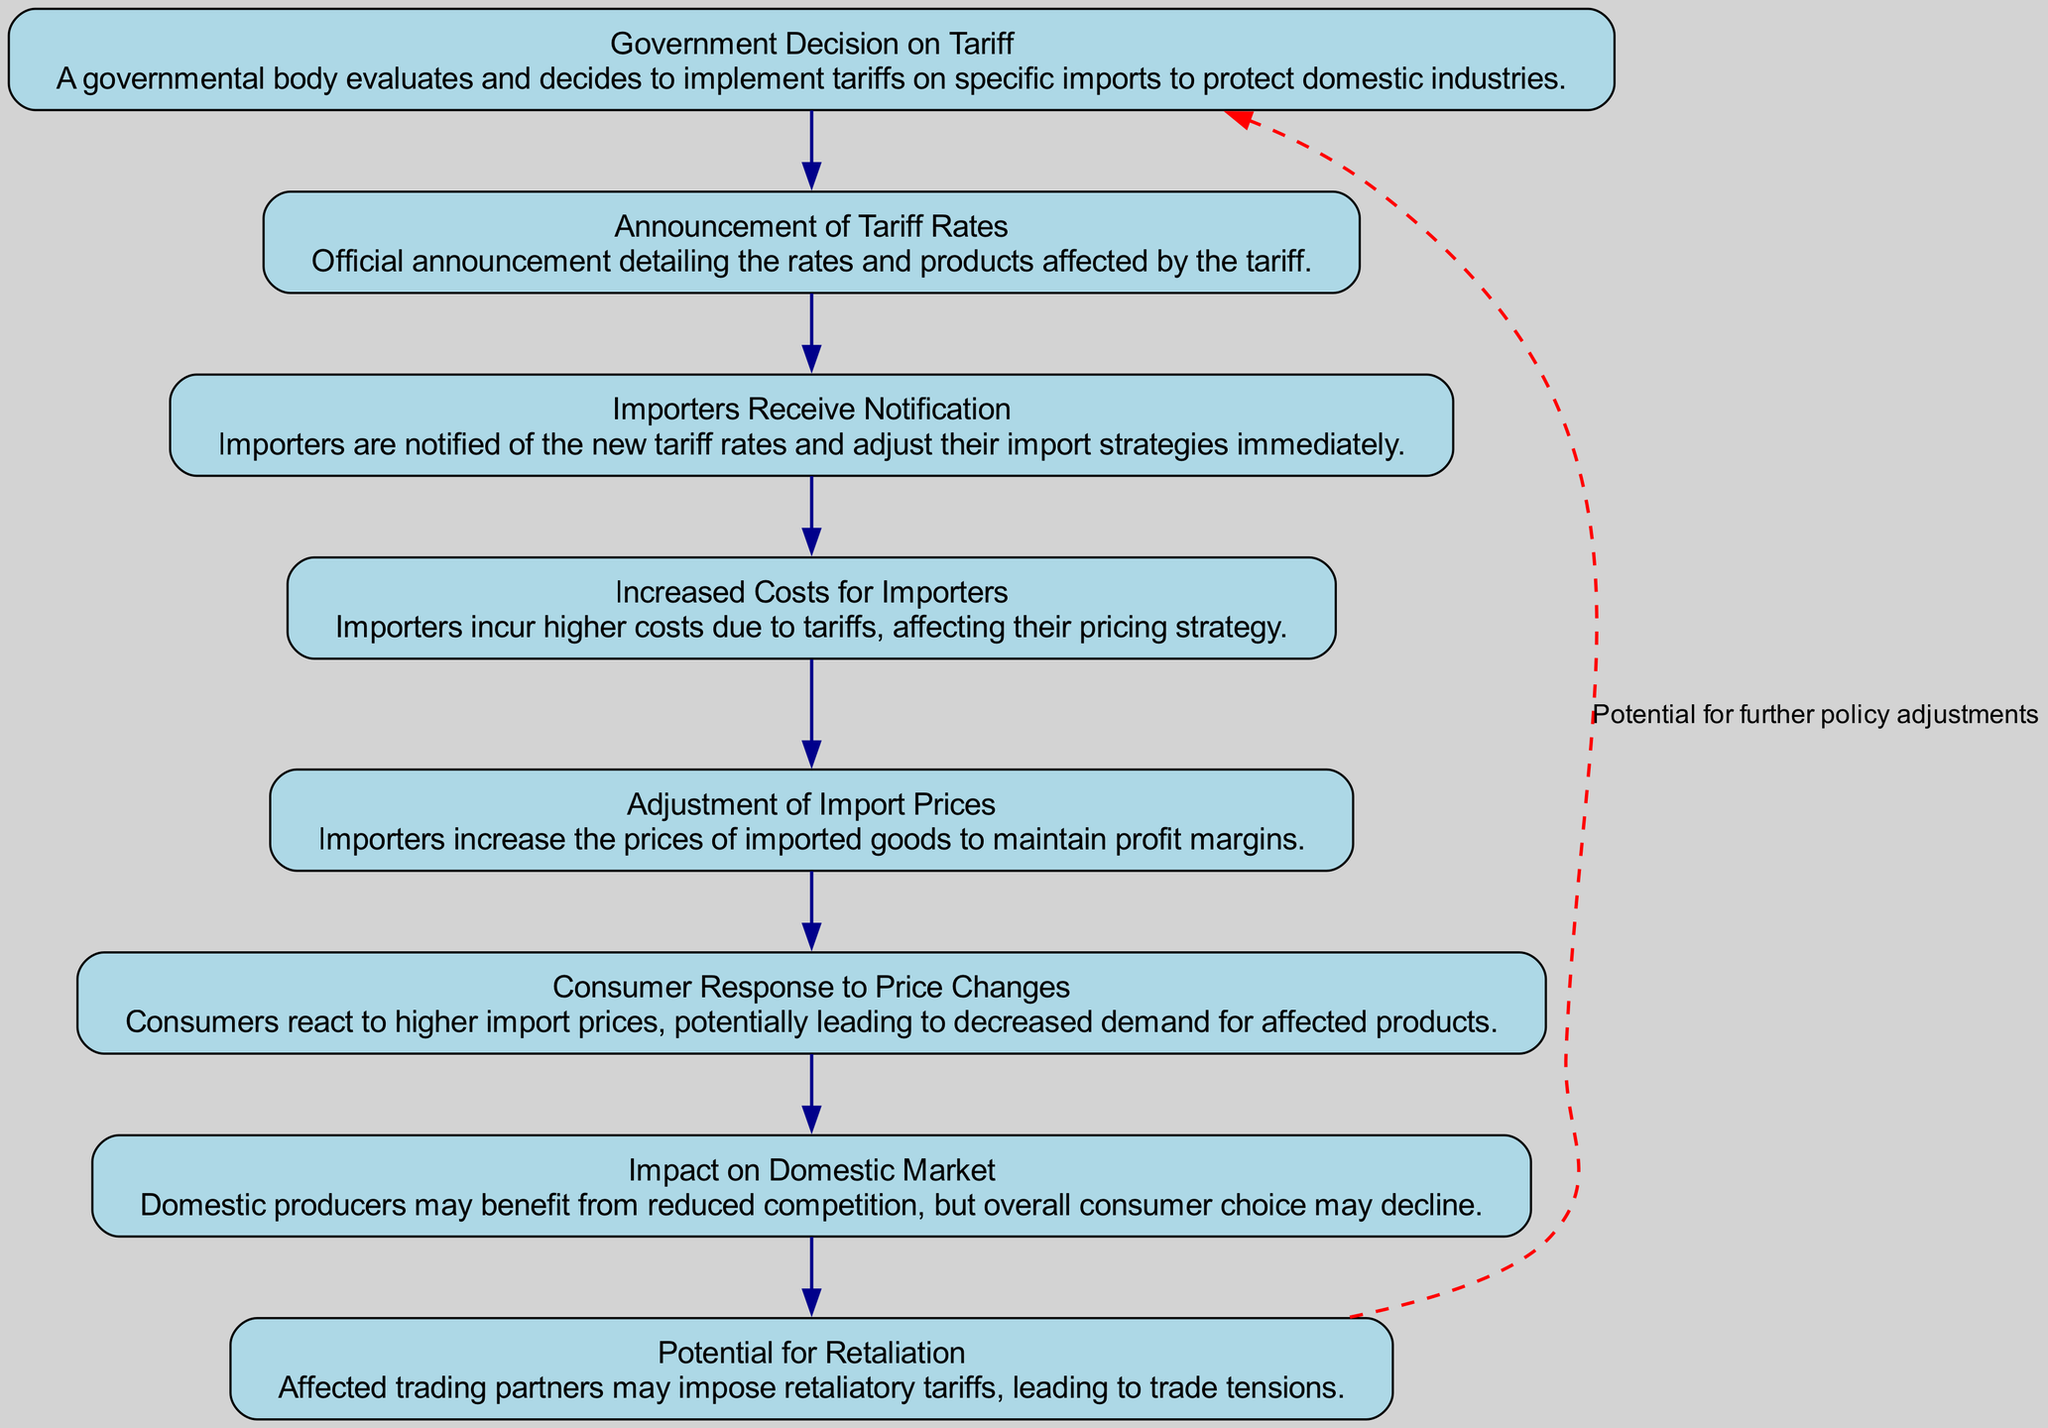What is the first step in the tariff implementation process? The first step is the "Government Decision on Tariff," where a governmental body evaluates and decides to implement tariffs.
Answer: Government Decision on Tariff How many nodes are there in the diagram? The diagram contains eight nodes, representing each key step in the tariff implementation process.
Answer: 8 What occurs immediately after the "Announcement of Tariff Rates"? Following the "Announcement of Tariff Rates," the next step is "Importers Receive Notification," where importers are informed of the new rates.
Answer: Importers Receive Notification Which element discusses the reaction of consumers? The element titled "Consumer Response to Price Changes" addresses how consumers react to the increased prices due to tariffs.
Answer: Consumer Response to Price Changes What is a potential consequence of tariffs mentioned in the diagram? The diagram mentions "Potential for Retaliation," indicating that affected trading partners may impose retaliatory tariffs as a consequence.
Answer: Potential for Retaliation What happens to import prices according to the flow chart? Import prices increase as a result of higher costs incurred by importers due to the tariffs.
Answer: Increased Costs for Importers Which node indicates a benefit for domestic producers? The node "Impact on Domestic Market" indicates that domestic producers may benefit from reduced competition resulting from tariff implementation.
Answer: Impact on Domestic Market What type of relationship is depicted between "Impact on Domestic Market" and "Potential for Retaliation"? The relationship suggests a cycle, with the potential for further policy adjustments indicated by a dashed red edge connecting the last node to the first.
Answer: Cycle What describes the final outcome for consumers in this diagram? The final outcome for consumers is a decline in overall choice as indicated by the "Impact on Domestic Market" node, as tariffs create reduced competition.
Answer: Decline in overall choice 